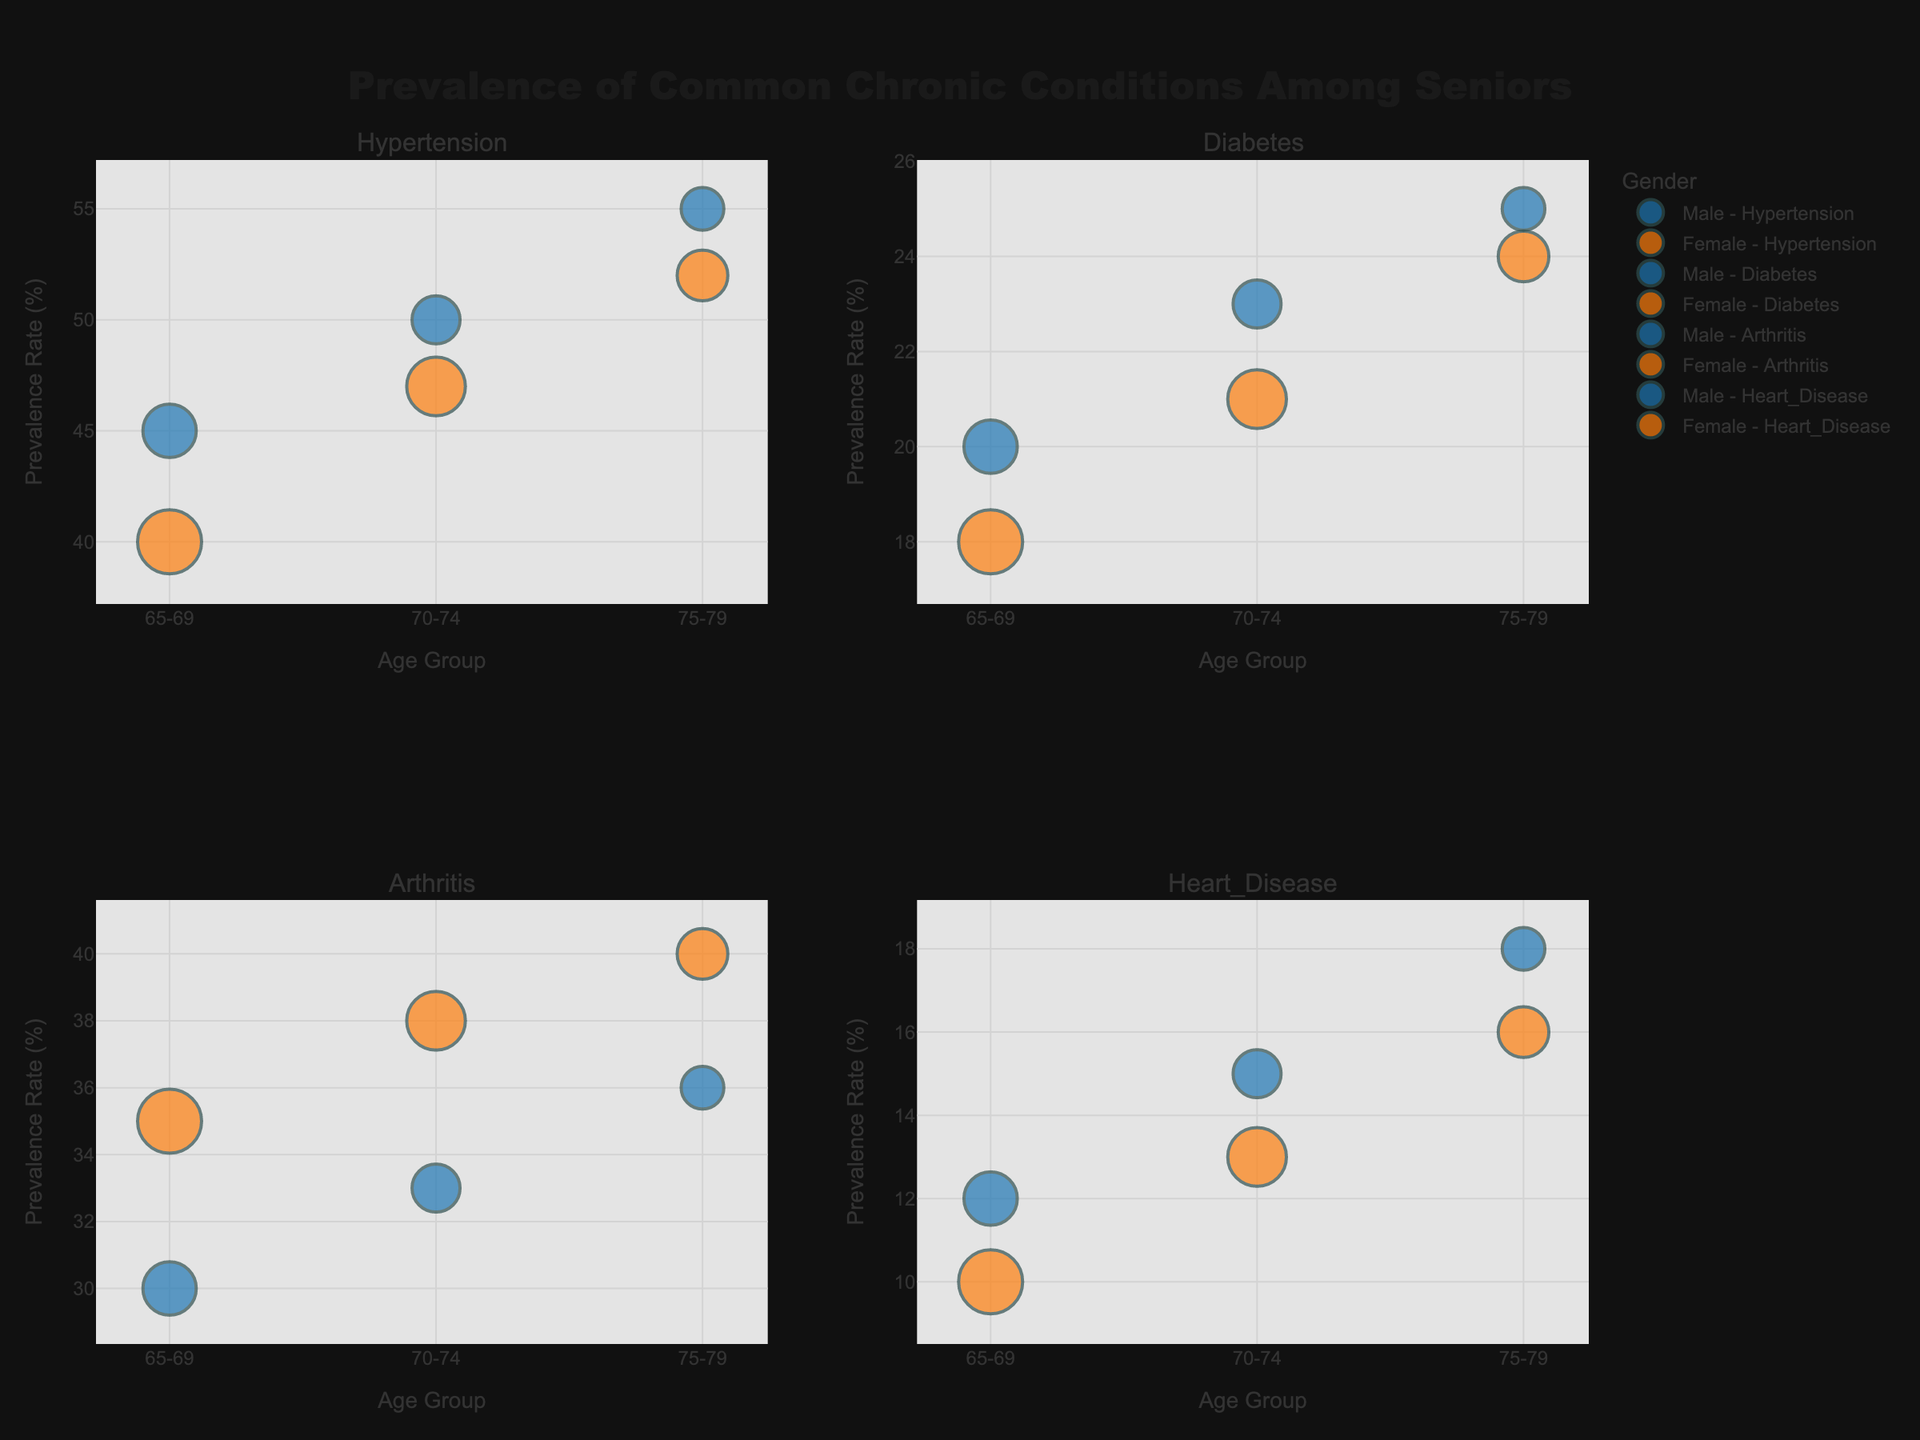What is the title of the figure? The title is located at the top-center of the figure and indicates what the visualizations represent.
Answer: Prevalence of Common Chronic Conditions Among Seniors How many subplots are there in the figure? Count the number of separate sections within the figure.
Answer: 4 What is the highest prevalence rate for arthritis in the 75-79 age group? Look at the subplot for Arthritis and find the point corresponding to the 75-79 age group.
Answer: 40% Which gender has a higher prevalence rate of diabetes in the 70-74 age group? Compare the prevalence rates for males and females in the 70-74 age group in the Diabetes subplot.
Answer: Male What is the population size for females with hypertension in the 65-69 age group? Look at the marker size for Females in the 65-69 age group in the Hypertension subplot, with text hover revealing exact size.
Answer: 1200 Which chronic condition shows the largest difference in prevalence rate between genders in the 65-69 age group? Compare the gender differences for each condition in the 65-69 age group.
Answer: Arthritis Is the prevalence rate of heart disease higher for males or females in the 75-79 age group? Check the Heart Disease subplot and compare the rates for both genders in the 75-79 age group.
Answer: Male What's the average prevalence rate of hypertension across all age groups for males? Calculate the average rate by summing up the prevalence rates for males in all age groups from the Hypertension subplot and divide by the number of age groups.
Answer: 50% Which chronic condition has the highest prevalence rate in the 75-79 age group for females? Examine all subplots and find the highest prevalence rate for females in the 75-79 age group.
Answer: Hypertension Which gender generally has a higher prevalence rate of arthritis across all age groups? Compare the prevalence rates for males and females across all age groups in the Arthritis subplot.
Answer: Female 